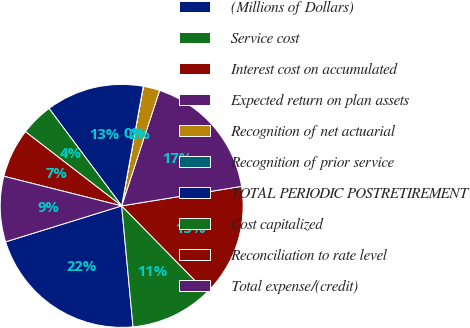<chart> <loc_0><loc_0><loc_500><loc_500><pie_chart><fcel>(Millions of Dollars)<fcel>Service cost<fcel>Interest cost on accumulated<fcel>Expected return on plan assets<fcel>Recognition of net actuarial<fcel>Recognition of prior service<fcel>TOTAL PERIODIC POSTRETIREMENT<fcel>Cost capitalized<fcel>Reconciliation to rate level<fcel>Total expense/(credit)<nl><fcel>21.71%<fcel>10.87%<fcel>15.21%<fcel>17.38%<fcel>2.19%<fcel>0.02%<fcel>13.04%<fcel>4.36%<fcel>6.53%<fcel>8.7%<nl></chart> 